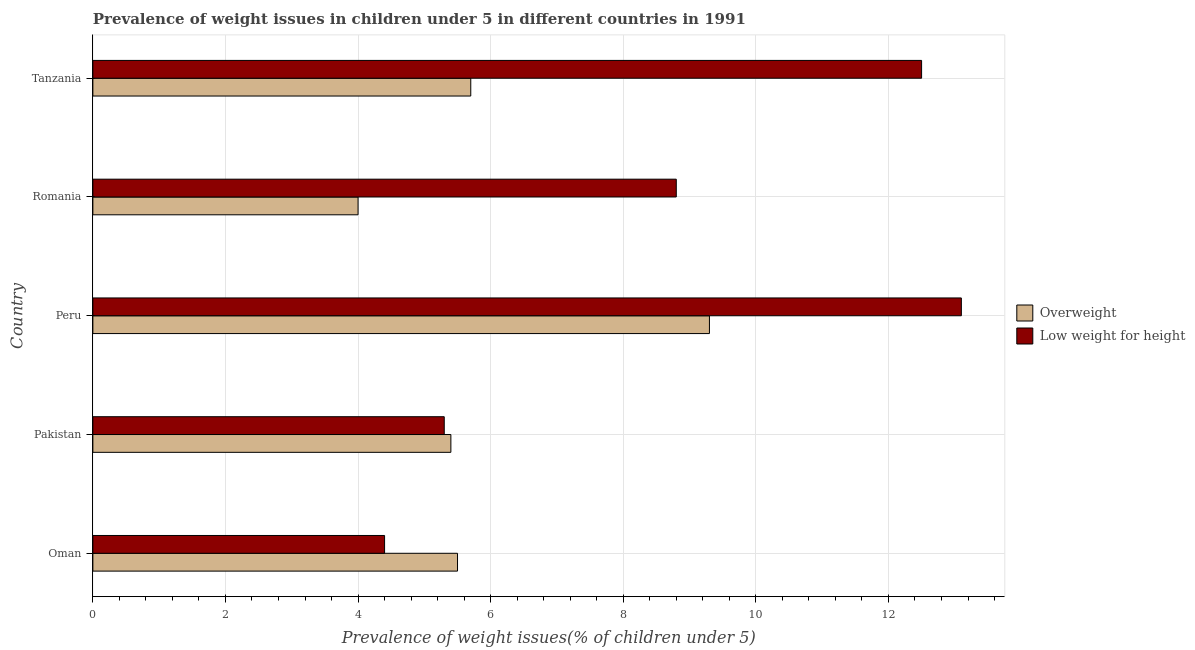How many different coloured bars are there?
Your answer should be very brief. 2. How many bars are there on the 1st tick from the top?
Ensure brevity in your answer.  2. What is the label of the 1st group of bars from the top?
Keep it short and to the point. Tanzania. In how many cases, is the number of bars for a given country not equal to the number of legend labels?
Your response must be concise. 0. What is the percentage of underweight children in Peru?
Your answer should be compact. 13.1. Across all countries, what is the maximum percentage of overweight children?
Give a very brief answer. 9.3. Across all countries, what is the minimum percentage of overweight children?
Your answer should be very brief. 4. In which country was the percentage of overweight children minimum?
Your answer should be compact. Romania. What is the total percentage of overweight children in the graph?
Make the answer very short. 29.9. What is the difference between the percentage of overweight children in Peru and the percentage of underweight children in Oman?
Ensure brevity in your answer.  4.9. What is the average percentage of overweight children per country?
Give a very brief answer. 5.98. What is the difference between the percentage of underweight children and percentage of overweight children in Romania?
Ensure brevity in your answer.  4.8. In how many countries, is the percentage of overweight children greater than 3.6 %?
Give a very brief answer. 5. What is the ratio of the percentage of overweight children in Oman to that in Pakistan?
Your answer should be compact. 1.02. Is the percentage of overweight children in Pakistan less than that in Romania?
Keep it short and to the point. No. In how many countries, is the percentage of overweight children greater than the average percentage of overweight children taken over all countries?
Your response must be concise. 1. What does the 2nd bar from the top in Peru represents?
Your answer should be compact. Overweight. What does the 1st bar from the bottom in Romania represents?
Offer a terse response. Overweight. How many bars are there?
Provide a short and direct response. 10. Are all the bars in the graph horizontal?
Your answer should be very brief. Yes. How many countries are there in the graph?
Make the answer very short. 5. What is the difference between two consecutive major ticks on the X-axis?
Make the answer very short. 2. Does the graph contain any zero values?
Provide a succinct answer. No. What is the title of the graph?
Keep it short and to the point. Prevalence of weight issues in children under 5 in different countries in 1991. What is the label or title of the X-axis?
Offer a terse response. Prevalence of weight issues(% of children under 5). What is the Prevalence of weight issues(% of children under 5) in Overweight in Oman?
Offer a very short reply. 5.5. What is the Prevalence of weight issues(% of children under 5) of Low weight for height in Oman?
Offer a very short reply. 4.4. What is the Prevalence of weight issues(% of children under 5) in Overweight in Pakistan?
Offer a very short reply. 5.4. What is the Prevalence of weight issues(% of children under 5) of Low weight for height in Pakistan?
Your response must be concise. 5.3. What is the Prevalence of weight issues(% of children under 5) of Overweight in Peru?
Offer a very short reply. 9.3. What is the Prevalence of weight issues(% of children under 5) in Low weight for height in Peru?
Provide a short and direct response. 13.1. What is the Prevalence of weight issues(% of children under 5) of Overweight in Romania?
Make the answer very short. 4. What is the Prevalence of weight issues(% of children under 5) in Low weight for height in Romania?
Provide a short and direct response. 8.8. What is the Prevalence of weight issues(% of children under 5) in Overweight in Tanzania?
Make the answer very short. 5.7. Across all countries, what is the maximum Prevalence of weight issues(% of children under 5) of Overweight?
Provide a succinct answer. 9.3. Across all countries, what is the maximum Prevalence of weight issues(% of children under 5) of Low weight for height?
Offer a terse response. 13.1. Across all countries, what is the minimum Prevalence of weight issues(% of children under 5) in Low weight for height?
Give a very brief answer. 4.4. What is the total Prevalence of weight issues(% of children under 5) in Overweight in the graph?
Ensure brevity in your answer.  29.9. What is the total Prevalence of weight issues(% of children under 5) in Low weight for height in the graph?
Give a very brief answer. 44.1. What is the difference between the Prevalence of weight issues(% of children under 5) in Low weight for height in Oman and that in Pakistan?
Provide a succinct answer. -0.9. What is the difference between the Prevalence of weight issues(% of children under 5) in Overweight in Oman and that in Peru?
Give a very brief answer. -3.8. What is the difference between the Prevalence of weight issues(% of children under 5) in Low weight for height in Oman and that in Peru?
Your response must be concise. -8.7. What is the difference between the Prevalence of weight issues(% of children under 5) in Overweight in Oman and that in Romania?
Your answer should be compact. 1.5. What is the difference between the Prevalence of weight issues(% of children under 5) in Low weight for height in Oman and that in Romania?
Your response must be concise. -4.4. What is the difference between the Prevalence of weight issues(% of children under 5) in Overweight in Oman and that in Tanzania?
Your answer should be compact. -0.2. What is the difference between the Prevalence of weight issues(% of children under 5) of Overweight in Pakistan and that in Peru?
Your answer should be very brief. -3.9. What is the difference between the Prevalence of weight issues(% of children under 5) in Overweight in Pakistan and that in Romania?
Your response must be concise. 1.4. What is the difference between the Prevalence of weight issues(% of children under 5) in Low weight for height in Pakistan and that in Romania?
Your answer should be compact. -3.5. What is the difference between the Prevalence of weight issues(% of children under 5) of Overweight in Pakistan and that in Tanzania?
Provide a short and direct response. -0.3. What is the difference between the Prevalence of weight issues(% of children under 5) of Low weight for height in Pakistan and that in Tanzania?
Your answer should be compact. -7.2. What is the difference between the Prevalence of weight issues(% of children under 5) of Low weight for height in Peru and that in Romania?
Your response must be concise. 4.3. What is the difference between the Prevalence of weight issues(% of children under 5) of Overweight in Romania and that in Tanzania?
Give a very brief answer. -1.7. What is the difference between the Prevalence of weight issues(% of children under 5) of Low weight for height in Romania and that in Tanzania?
Offer a terse response. -3.7. What is the difference between the Prevalence of weight issues(% of children under 5) in Overweight in Oman and the Prevalence of weight issues(% of children under 5) in Low weight for height in Pakistan?
Your response must be concise. 0.2. What is the difference between the Prevalence of weight issues(% of children under 5) of Overweight in Oman and the Prevalence of weight issues(% of children under 5) of Low weight for height in Peru?
Give a very brief answer. -7.6. What is the difference between the Prevalence of weight issues(% of children under 5) of Overweight in Oman and the Prevalence of weight issues(% of children under 5) of Low weight for height in Romania?
Ensure brevity in your answer.  -3.3. What is the difference between the Prevalence of weight issues(% of children under 5) in Overweight in Oman and the Prevalence of weight issues(% of children under 5) in Low weight for height in Tanzania?
Ensure brevity in your answer.  -7. What is the difference between the Prevalence of weight issues(% of children under 5) in Overweight in Pakistan and the Prevalence of weight issues(% of children under 5) in Low weight for height in Romania?
Ensure brevity in your answer.  -3.4. What is the difference between the Prevalence of weight issues(% of children under 5) of Overweight in Peru and the Prevalence of weight issues(% of children under 5) of Low weight for height in Romania?
Your response must be concise. 0.5. What is the difference between the Prevalence of weight issues(% of children under 5) in Overweight in Romania and the Prevalence of weight issues(% of children under 5) in Low weight for height in Tanzania?
Offer a terse response. -8.5. What is the average Prevalence of weight issues(% of children under 5) of Overweight per country?
Provide a short and direct response. 5.98. What is the average Prevalence of weight issues(% of children under 5) in Low weight for height per country?
Provide a short and direct response. 8.82. What is the difference between the Prevalence of weight issues(% of children under 5) of Overweight and Prevalence of weight issues(% of children under 5) of Low weight for height in Oman?
Offer a terse response. 1.1. What is the difference between the Prevalence of weight issues(% of children under 5) of Overweight and Prevalence of weight issues(% of children under 5) of Low weight for height in Romania?
Provide a succinct answer. -4.8. What is the ratio of the Prevalence of weight issues(% of children under 5) of Overweight in Oman to that in Pakistan?
Your answer should be compact. 1.02. What is the ratio of the Prevalence of weight issues(% of children under 5) of Low weight for height in Oman to that in Pakistan?
Your response must be concise. 0.83. What is the ratio of the Prevalence of weight issues(% of children under 5) of Overweight in Oman to that in Peru?
Your answer should be very brief. 0.59. What is the ratio of the Prevalence of weight issues(% of children under 5) of Low weight for height in Oman to that in Peru?
Provide a short and direct response. 0.34. What is the ratio of the Prevalence of weight issues(% of children under 5) of Overweight in Oman to that in Romania?
Offer a terse response. 1.38. What is the ratio of the Prevalence of weight issues(% of children under 5) of Low weight for height in Oman to that in Romania?
Ensure brevity in your answer.  0.5. What is the ratio of the Prevalence of weight issues(% of children under 5) in Overweight in Oman to that in Tanzania?
Keep it short and to the point. 0.96. What is the ratio of the Prevalence of weight issues(% of children under 5) in Low weight for height in Oman to that in Tanzania?
Ensure brevity in your answer.  0.35. What is the ratio of the Prevalence of weight issues(% of children under 5) in Overweight in Pakistan to that in Peru?
Make the answer very short. 0.58. What is the ratio of the Prevalence of weight issues(% of children under 5) in Low weight for height in Pakistan to that in Peru?
Offer a very short reply. 0.4. What is the ratio of the Prevalence of weight issues(% of children under 5) of Overweight in Pakistan to that in Romania?
Provide a succinct answer. 1.35. What is the ratio of the Prevalence of weight issues(% of children under 5) in Low weight for height in Pakistan to that in Romania?
Ensure brevity in your answer.  0.6. What is the ratio of the Prevalence of weight issues(% of children under 5) in Low weight for height in Pakistan to that in Tanzania?
Keep it short and to the point. 0.42. What is the ratio of the Prevalence of weight issues(% of children under 5) of Overweight in Peru to that in Romania?
Offer a terse response. 2.33. What is the ratio of the Prevalence of weight issues(% of children under 5) of Low weight for height in Peru to that in Romania?
Your answer should be very brief. 1.49. What is the ratio of the Prevalence of weight issues(% of children under 5) of Overweight in Peru to that in Tanzania?
Your answer should be compact. 1.63. What is the ratio of the Prevalence of weight issues(% of children under 5) in Low weight for height in Peru to that in Tanzania?
Provide a succinct answer. 1.05. What is the ratio of the Prevalence of weight issues(% of children under 5) in Overweight in Romania to that in Tanzania?
Ensure brevity in your answer.  0.7. What is the ratio of the Prevalence of weight issues(% of children under 5) in Low weight for height in Romania to that in Tanzania?
Keep it short and to the point. 0.7. What is the difference between the highest and the second highest Prevalence of weight issues(% of children under 5) in Overweight?
Your answer should be compact. 3.6. What is the difference between the highest and the second highest Prevalence of weight issues(% of children under 5) in Low weight for height?
Your response must be concise. 0.6. 